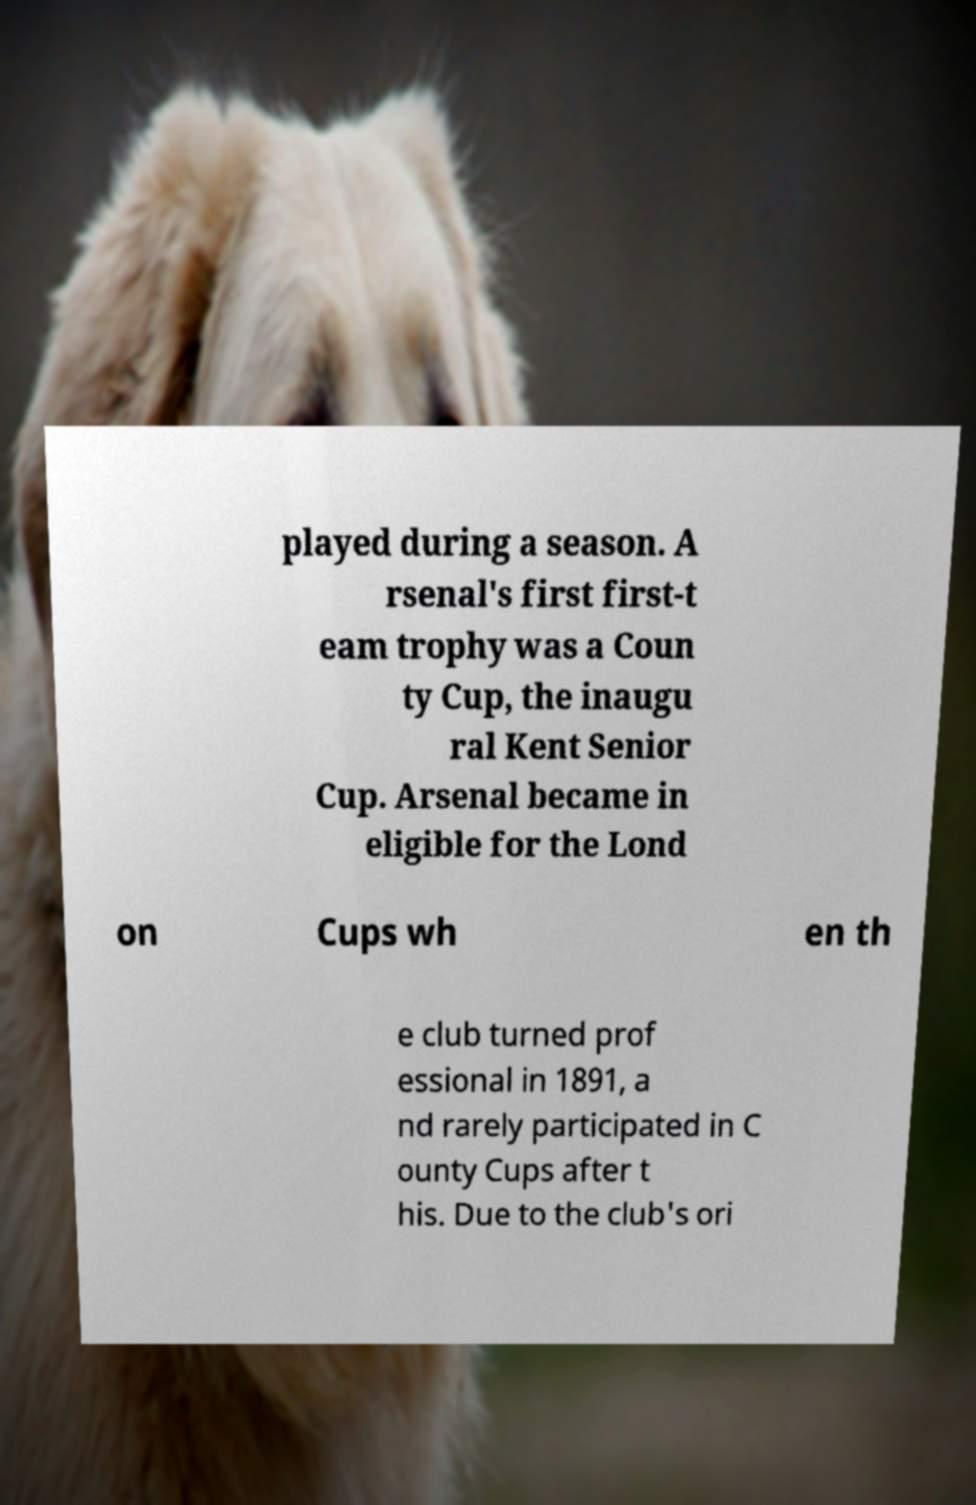I need the written content from this picture converted into text. Can you do that? played during a season. A rsenal's first first-t eam trophy was a Coun ty Cup, the inaugu ral Kent Senior Cup. Arsenal became in eligible for the Lond on Cups wh en th e club turned prof essional in 1891, a nd rarely participated in C ounty Cups after t his. Due to the club's ori 